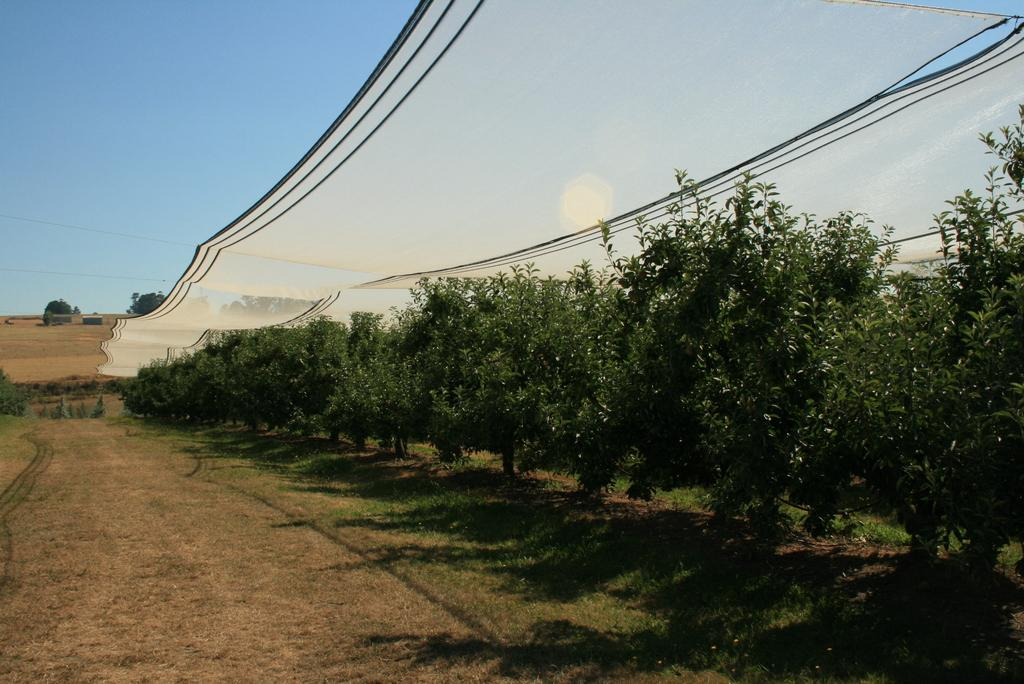What type of vegetation is present in the image? There are trees with branches and leaves in the image. What is hanging above the trees? There is a cloth hanging above the trees. What part of the natural environment is visible in the image? The sky is visible in the image. What type of furniture can be seen in the image? There is no furniture present in the image; it features trees, a cloth, and the sky. What color is the skirt worn by the tree in the image? There is no tree wearing a skirt in the image; trees have branches and leaves. 